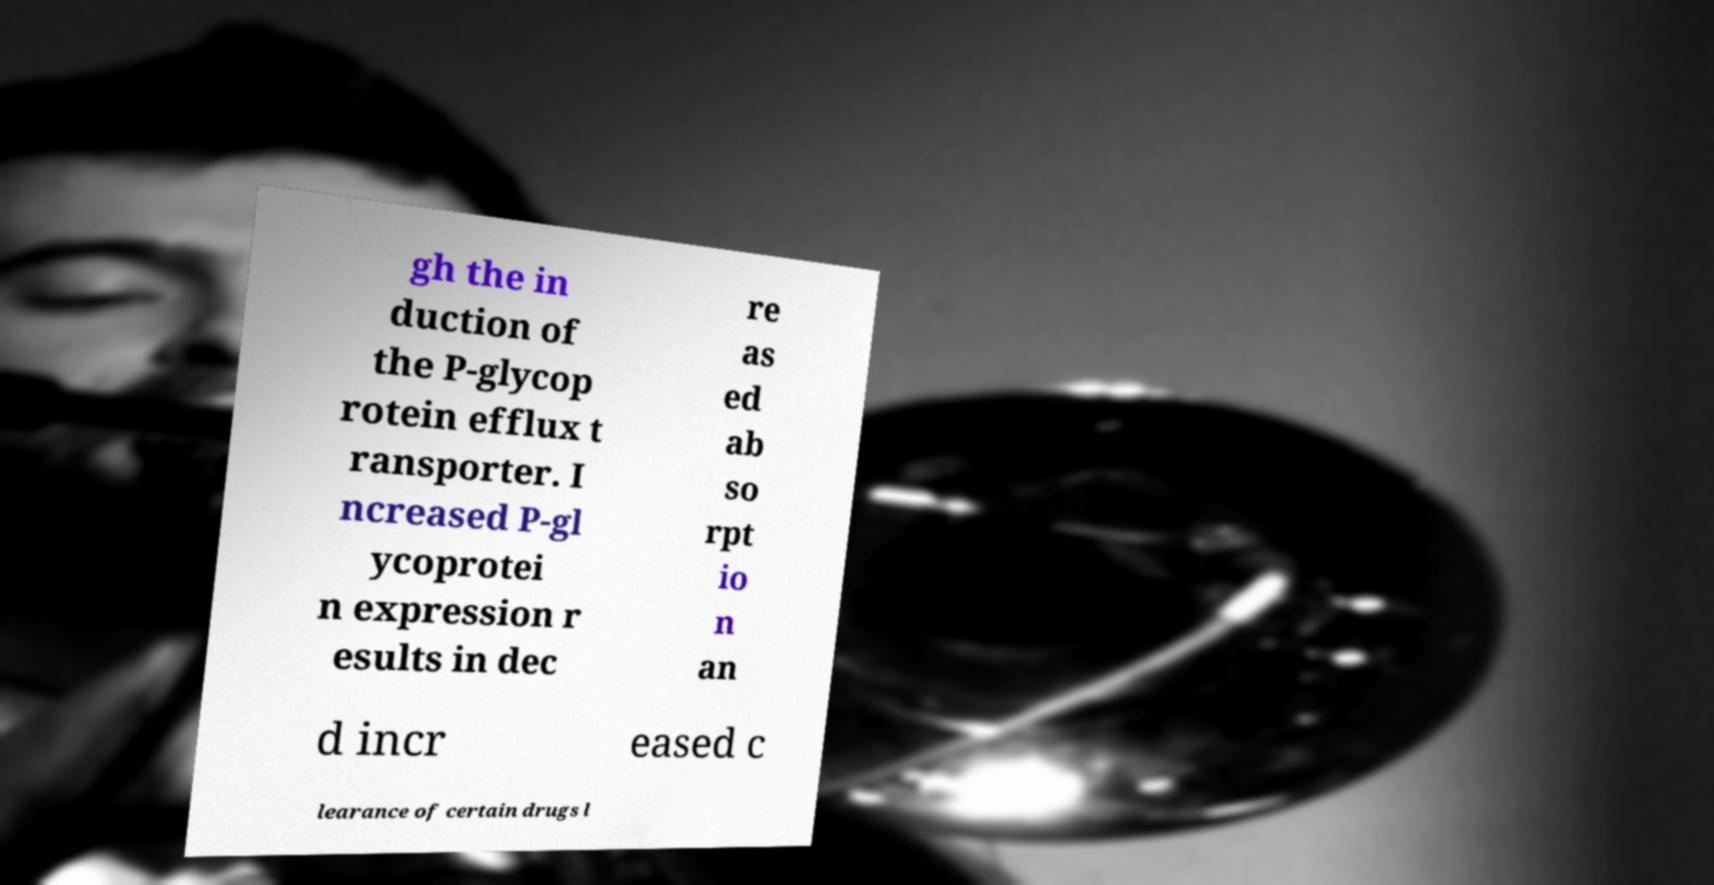Can you read and provide the text displayed in the image?This photo seems to have some interesting text. Can you extract and type it out for me? gh the in duction of the P-glycop rotein efflux t ransporter. I ncreased P-gl ycoprotei n expression r esults in dec re as ed ab so rpt io n an d incr eased c learance of certain drugs l 